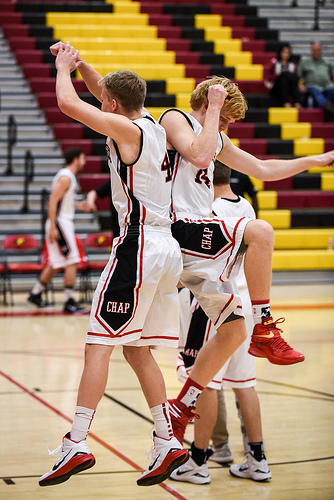<image>
Can you confirm if the basketball player is on the floor? No. The basketball player is not positioned on the floor. They may be near each other, but the basketball player is not supported by or resting on top of the floor. Where is the bleachers in relation to the shoe? Is it above the shoe? No. The bleachers is not positioned above the shoe. The vertical arrangement shows a different relationship. 